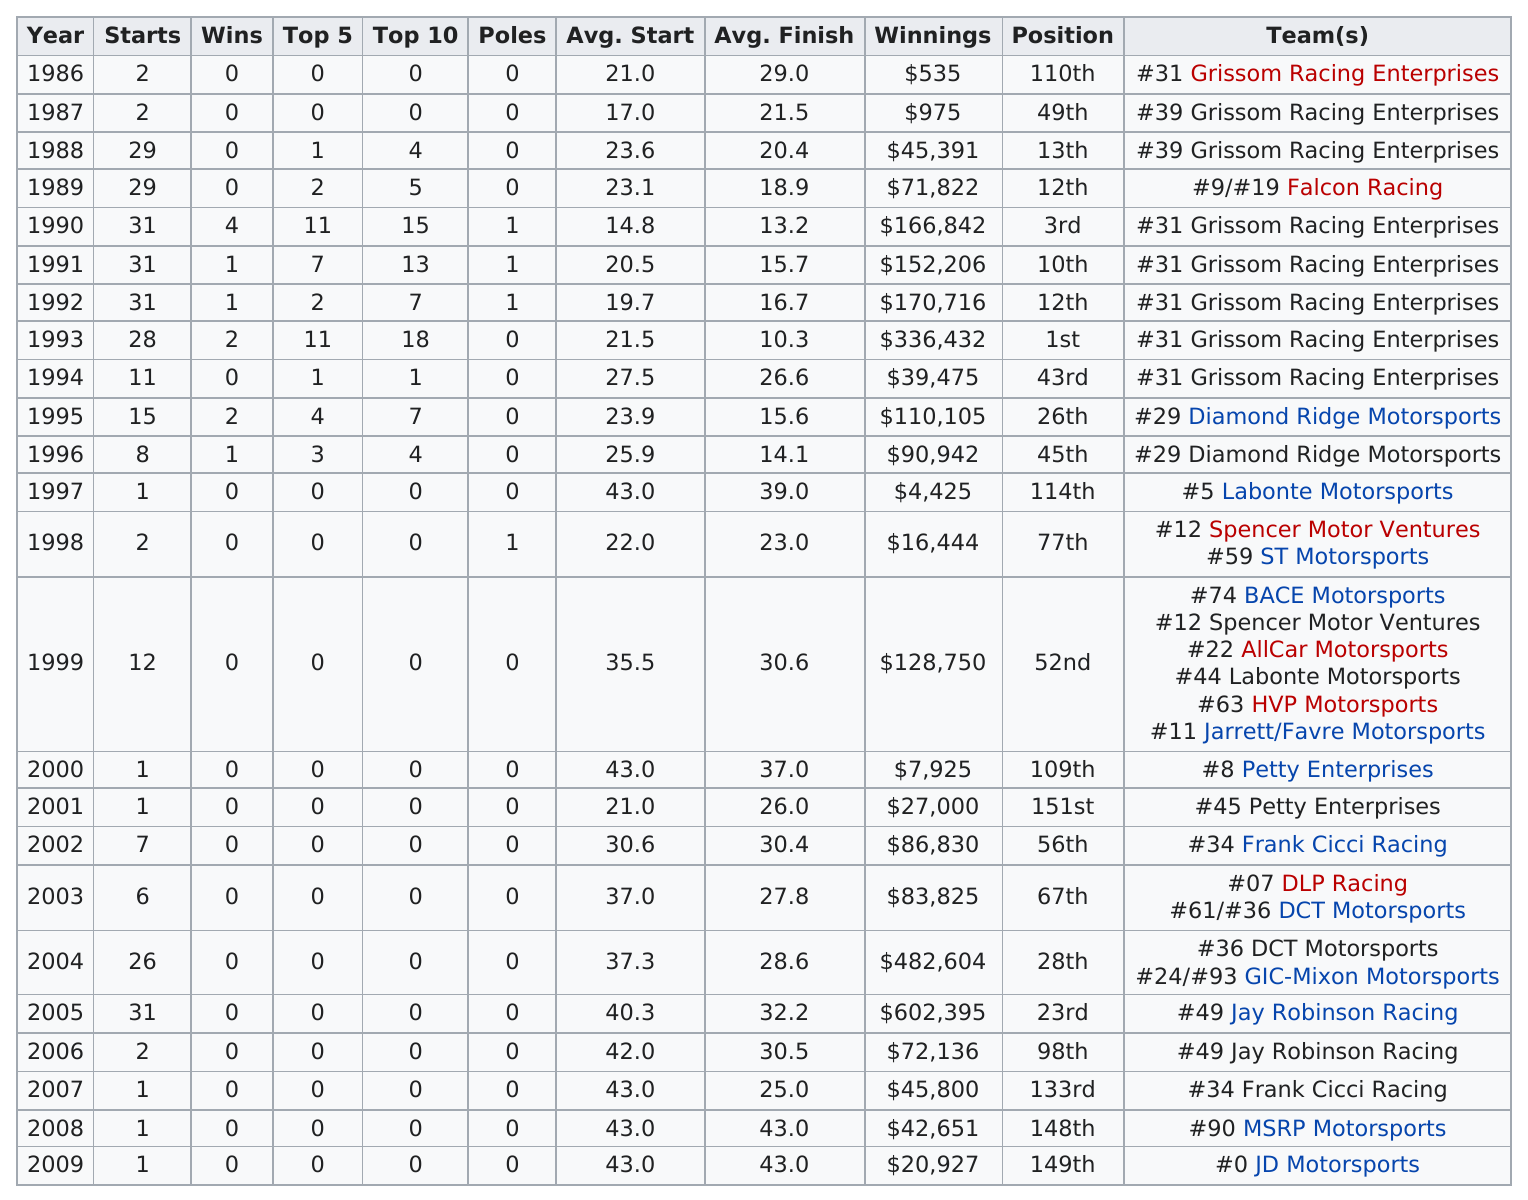Specify some key components in this picture. In his first year competing in the nationwide series, Grissom won a total of $535 in prize money. In 1988, Steve Grissom had a top 5 finish in the Nationwide Series. During the years 1986 to 1996, a total of five teams earned winnings above $100,000. In 1986, the average start time was X, while in 2009, the average start time was Y, where X and Y are two numbers. His greatest yearly winnings exceed his least by $601,860. 